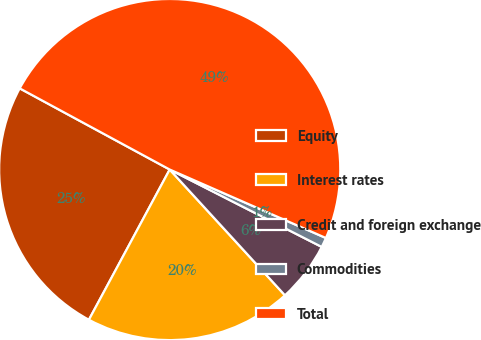Convert chart. <chart><loc_0><loc_0><loc_500><loc_500><pie_chart><fcel>Equity<fcel>Interest rates<fcel>Credit and foreign exchange<fcel>Commodities<fcel>Total<nl><fcel>25.04%<fcel>19.66%<fcel>5.7%<fcel>0.92%<fcel>48.68%<nl></chart> 